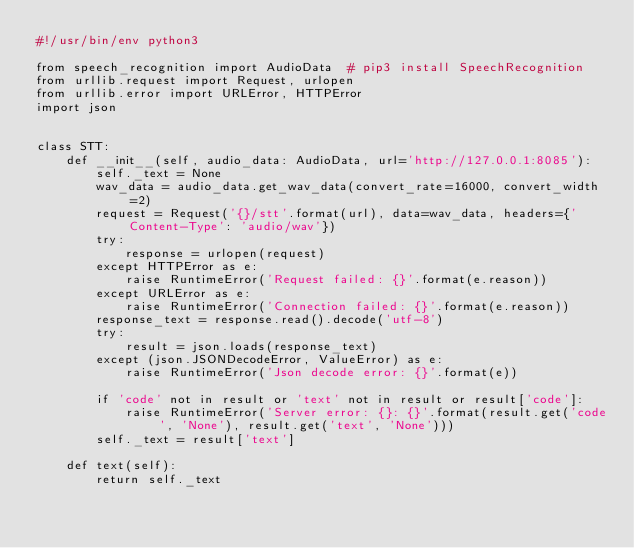Convert code to text. <code><loc_0><loc_0><loc_500><loc_500><_Python_>#!/usr/bin/env python3

from speech_recognition import AudioData  # pip3 install SpeechRecognition
from urllib.request import Request, urlopen
from urllib.error import URLError, HTTPError
import json


class STT:
    def __init__(self, audio_data: AudioData, url='http://127.0.0.1:8085'):
        self._text = None
        wav_data = audio_data.get_wav_data(convert_rate=16000, convert_width=2)
        request = Request('{}/stt'.format(url), data=wav_data, headers={'Content-Type': 'audio/wav'})
        try:
            response = urlopen(request)
        except HTTPError as e:
            raise RuntimeError('Request failed: {}'.format(e.reason))
        except URLError as e:
            raise RuntimeError('Connection failed: {}'.format(e.reason))
        response_text = response.read().decode('utf-8')
        try:
            result = json.loads(response_text)
        except (json.JSONDecodeError, ValueError) as e:
            raise RuntimeError('Json decode error: {}'.format(e))

        if 'code' not in result or 'text' not in result or result['code']:
            raise RuntimeError('Server error: {}: {}'.format(result.get('code', 'None'), result.get('text', 'None')))
        self._text = result['text']

    def text(self):
        return self._text
</code> 